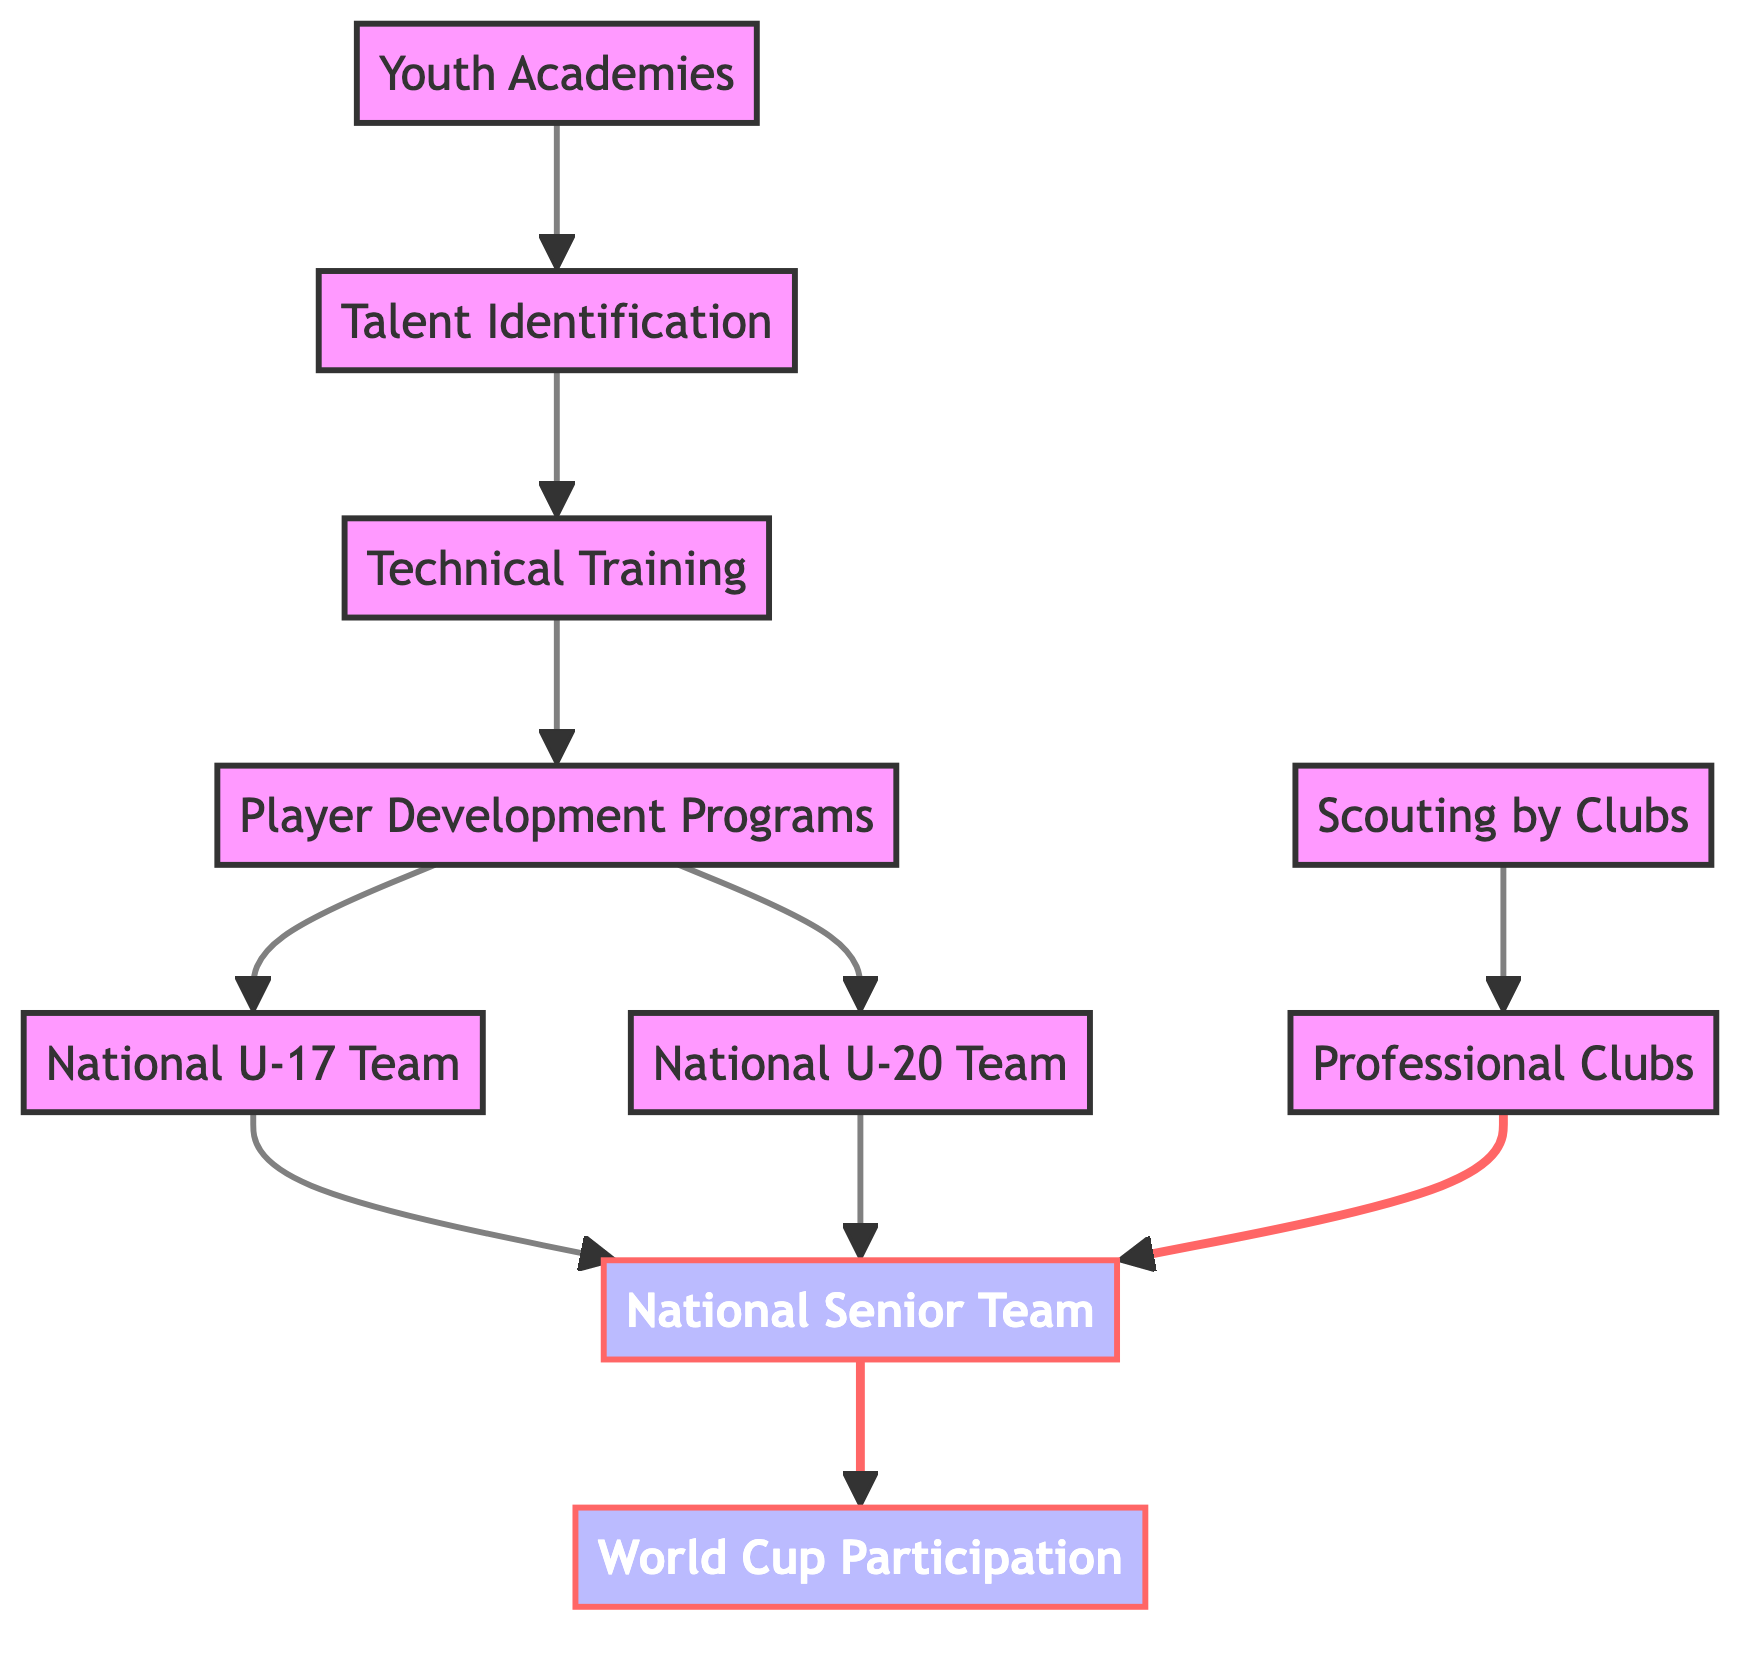What is the first step in player development leading to World Cup participation? The first step in the diagram is represented by the node "Youth Academies," which is the starting point for player development.
Answer: Youth Academies How many nodes are present in the diagram? By counting each unique entity represented in the diagram, we find there are 10 nodes detailing different aspects of player development and World Cup participation.
Answer: 10 Which teams are directly connected to the National Senior Team? The National Senior Team is connected directly to the National U-17 Team and the National U-20 Team in the development pathway, as indicated by the edges leading to the Senior Team node.
Answer: National U-17 Team, National U-20 Team What type of clubs scout for players according to the diagram? The diagram indicates that "Clubs" are involved in scouting, specifically labeled as "Scouting by Clubs," which leads to identifying professional players.
Answer: Scouting by Clubs What is the final outcome in the pathway depicted in the diagram? The ultimate outcome of the player development pathway, as shown in the diagram, leads to "World Cup Participation," which is the end goal of the entire process.
Answer: World Cup Participation Which player development program leads to the National U-20 Team? According to the diagram, the "Player Development Programs" node has a direct connection to the "National U-20 Team," indicating it is a pathway toward that level of national team participation.
Answer: Player Development Programs How many pathways lead to the National Senior Team? There are three distinct pathways leading to the National Senior Team: one from the National U-17 Team, one from the National U-20 Team, and another from Professional Clubs, making a total of three routes.
Answer: 3 Which node is not directly connected to any national team? The node "Professional Clubs" is not directly connected to any national team in the diagram, but it connects to scouting, which in turn affects the Senior Team.
Answer: Professional Clubs What follows talent identification in the development process? Following "Talent Identification," the next stage in the process as depicted in the diagram is "Technical Training," which prepares the identified talent for further development.
Answer: Technical Training 